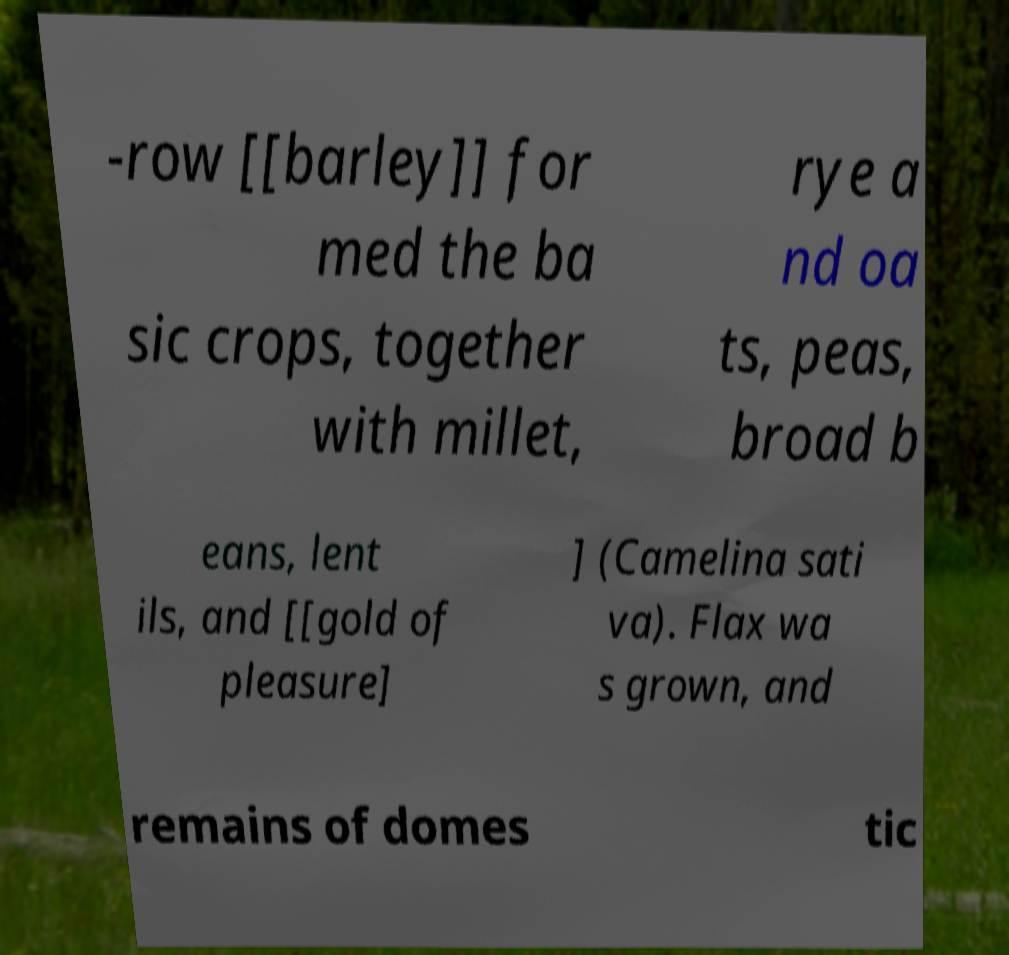Please read and relay the text visible in this image. What does it say? -row [[barley]] for med the ba sic crops, together with millet, rye a nd oa ts, peas, broad b eans, lent ils, and [[gold of pleasure] ] (Camelina sati va). Flax wa s grown, and remains of domes tic 